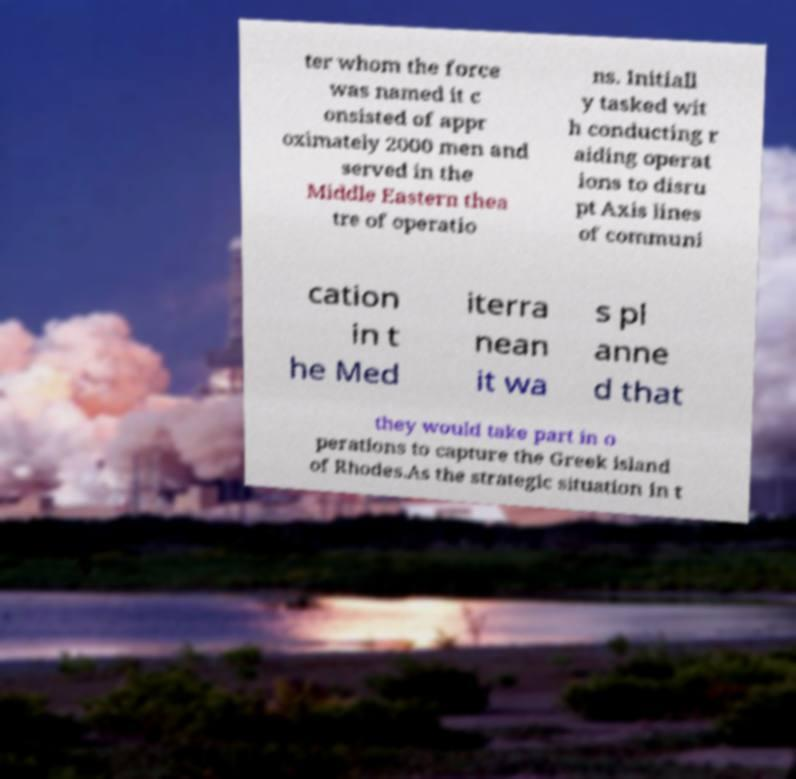Could you extract and type out the text from this image? ter whom the force was named it c onsisted of appr oximately 2000 men and served in the Middle Eastern thea tre of operatio ns. Initiall y tasked wit h conducting r aiding operat ions to disru pt Axis lines of communi cation in t he Med iterra nean it wa s pl anne d that they would take part in o perations to capture the Greek island of Rhodes.As the strategic situation in t 